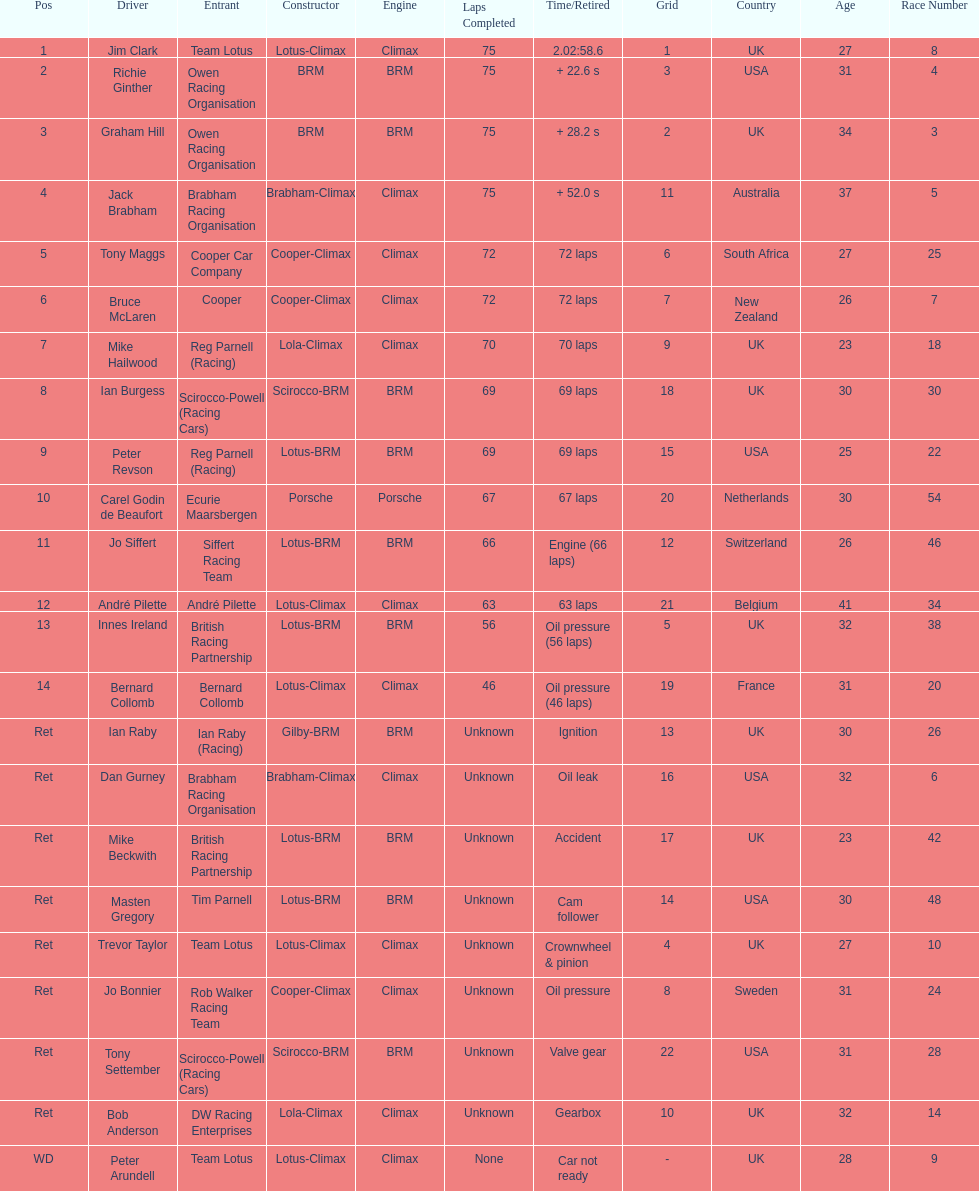Who are all the drivers? Jim Clark, Richie Ginther, Graham Hill, Jack Brabham, Tony Maggs, Bruce McLaren, Mike Hailwood, Ian Burgess, Peter Revson, Carel Godin de Beaufort, Jo Siffert, André Pilette, Innes Ireland, Bernard Collomb, Ian Raby, Dan Gurney, Mike Beckwith, Masten Gregory, Trevor Taylor, Jo Bonnier, Tony Settember, Bob Anderson, Peter Arundell. Which drove a cooper-climax? Tony Maggs, Bruce McLaren, Jo Bonnier. Of those, who was the top finisher? Tony Maggs. 